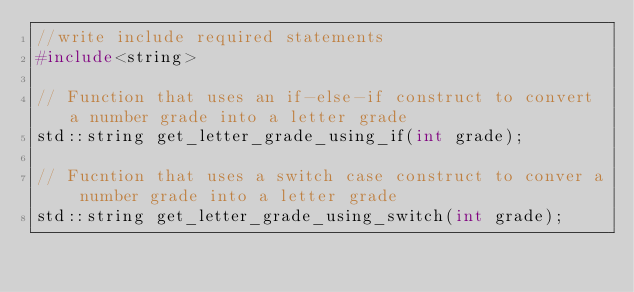<code> <loc_0><loc_0><loc_500><loc_500><_C_>//write include required statements
#include<string>

// Function that uses an if-else-if construct to convert a number grade into a letter grade
std::string get_letter_grade_using_if(int grade);

// Fucntion that uses a switch case construct to conver a number grade into a letter grade
std::string get_letter_grade_using_switch(int grade);
</code> 